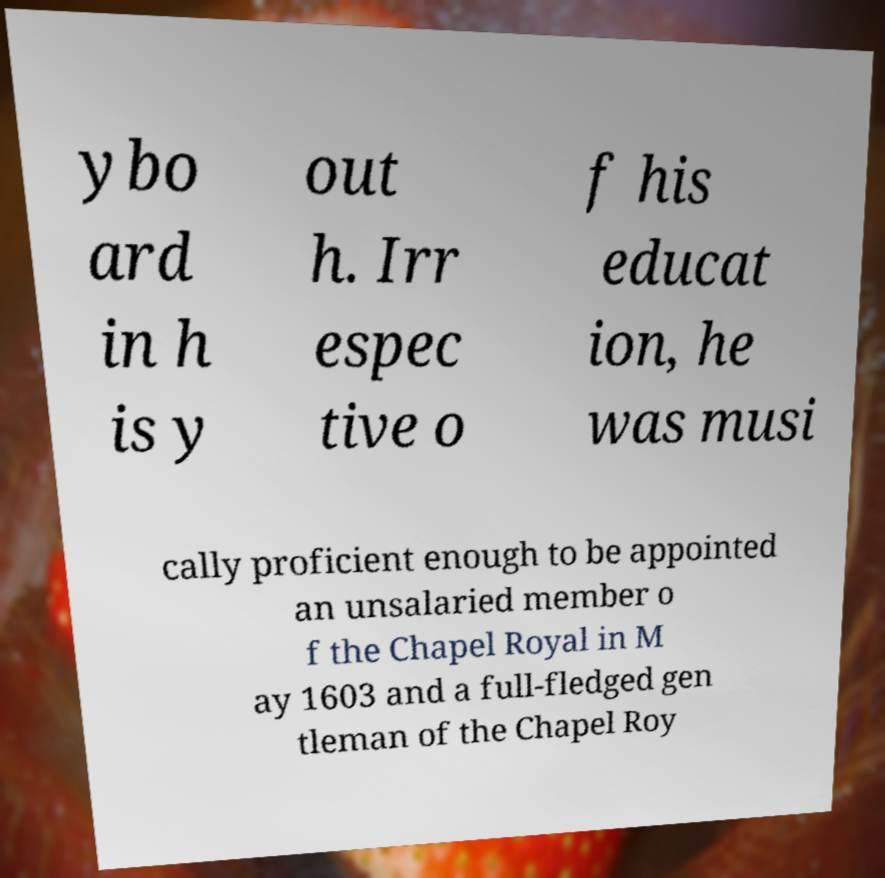What messages or text are displayed in this image? I need them in a readable, typed format. ybo ard in h is y out h. Irr espec tive o f his educat ion, he was musi cally proficient enough to be appointed an unsalaried member o f the Chapel Royal in M ay 1603 and a full-fledged gen tleman of the Chapel Roy 